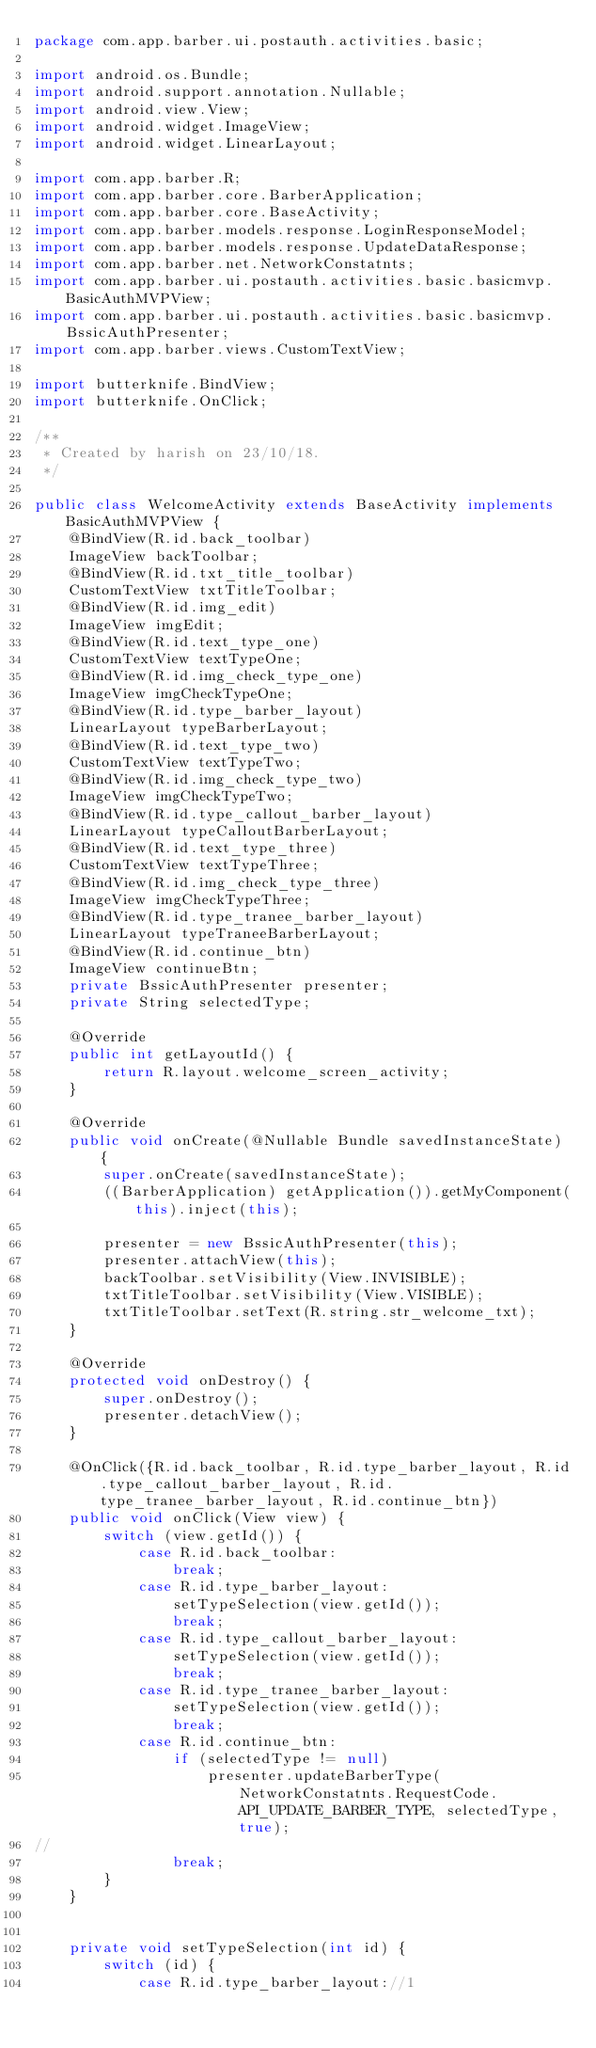<code> <loc_0><loc_0><loc_500><loc_500><_Java_>package com.app.barber.ui.postauth.activities.basic;

import android.os.Bundle;
import android.support.annotation.Nullable;
import android.view.View;
import android.widget.ImageView;
import android.widget.LinearLayout;

import com.app.barber.R;
import com.app.barber.core.BarberApplication;
import com.app.barber.core.BaseActivity;
import com.app.barber.models.response.LoginResponseModel;
import com.app.barber.models.response.UpdateDataResponse;
import com.app.barber.net.NetworkConstatnts;
import com.app.barber.ui.postauth.activities.basic.basicmvp.BasicAuthMVPView;
import com.app.barber.ui.postauth.activities.basic.basicmvp.BssicAuthPresenter;
import com.app.barber.views.CustomTextView;

import butterknife.BindView;
import butterknife.OnClick;

/**
 * Created by harish on 23/10/18.
 */

public class WelcomeActivity extends BaseActivity implements BasicAuthMVPView {
    @BindView(R.id.back_toolbar)
    ImageView backToolbar;
    @BindView(R.id.txt_title_toolbar)
    CustomTextView txtTitleToolbar;
    @BindView(R.id.img_edit)
    ImageView imgEdit;
    @BindView(R.id.text_type_one)
    CustomTextView textTypeOne;
    @BindView(R.id.img_check_type_one)
    ImageView imgCheckTypeOne;
    @BindView(R.id.type_barber_layout)
    LinearLayout typeBarberLayout;
    @BindView(R.id.text_type_two)
    CustomTextView textTypeTwo;
    @BindView(R.id.img_check_type_two)
    ImageView imgCheckTypeTwo;
    @BindView(R.id.type_callout_barber_layout)
    LinearLayout typeCalloutBarberLayout;
    @BindView(R.id.text_type_three)
    CustomTextView textTypeThree;
    @BindView(R.id.img_check_type_three)
    ImageView imgCheckTypeThree;
    @BindView(R.id.type_tranee_barber_layout)
    LinearLayout typeTraneeBarberLayout;
    @BindView(R.id.continue_btn)
    ImageView continueBtn;
    private BssicAuthPresenter presenter;
    private String selectedType;

    @Override
    public int getLayoutId() {
        return R.layout.welcome_screen_activity;
    }

    @Override
    public void onCreate(@Nullable Bundle savedInstanceState) {
        super.onCreate(savedInstanceState);
        ((BarberApplication) getApplication()).getMyComponent(this).inject(this);

        presenter = new BssicAuthPresenter(this);
        presenter.attachView(this);
        backToolbar.setVisibility(View.INVISIBLE);
        txtTitleToolbar.setVisibility(View.VISIBLE);
        txtTitleToolbar.setText(R.string.str_welcome_txt);
    }

    @Override
    protected void onDestroy() {
        super.onDestroy();
        presenter.detachView();
    }

    @OnClick({R.id.back_toolbar, R.id.type_barber_layout, R.id.type_callout_barber_layout, R.id.type_tranee_barber_layout, R.id.continue_btn})
    public void onClick(View view) {
        switch (view.getId()) {
            case R.id.back_toolbar:
                break;
            case R.id.type_barber_layout:
                setTypeSelection(view.getId());
                break;
            case R.id.type_callout_barber_layout:
                setTypeSelection(view.getId());
                break;
            case R.id.type_tranee_barber_layout:
                setTypeSelection(view.getId());
                break;
            case R.id.continue_btn:
                if (selectedType != null)
                    presenter.updateBarberType(NetworkConstatnts.RequestCode.API_UPDATE_BARBER_TYPE, selectedType, true);
//
                break;
        }
    }


    private void setTypeSelection(int id) {
        switch (id) {
            case R.id.type_barber_layout://1</code> 